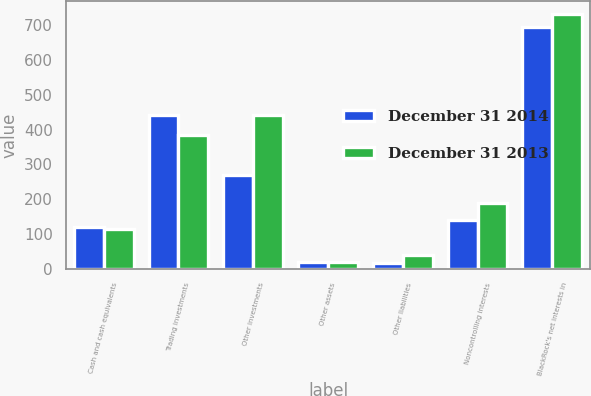<chart> <loc_0><loc_0><loc_500><loc_500><stacked_bar_chart><ecel><fcel>Cash and cash equivalents<fcel>Trading investments<fcel>Other investments<fcel>Other assets<fcel>Other liabilities<fcel>Noncontrolling interests<fcel>BlackRock's net interests in<nl><fcel>December 31 2014<fcel>120<fcel>443<fcel>270<fcel>20<fcel>18<fcel>139<fcel>696<nl><fcel>December 31 2013<fcel>114<fcel>385<fcel>441<fcel>20<fcel>39<fcel>189<fcel>732<nl></chart> 